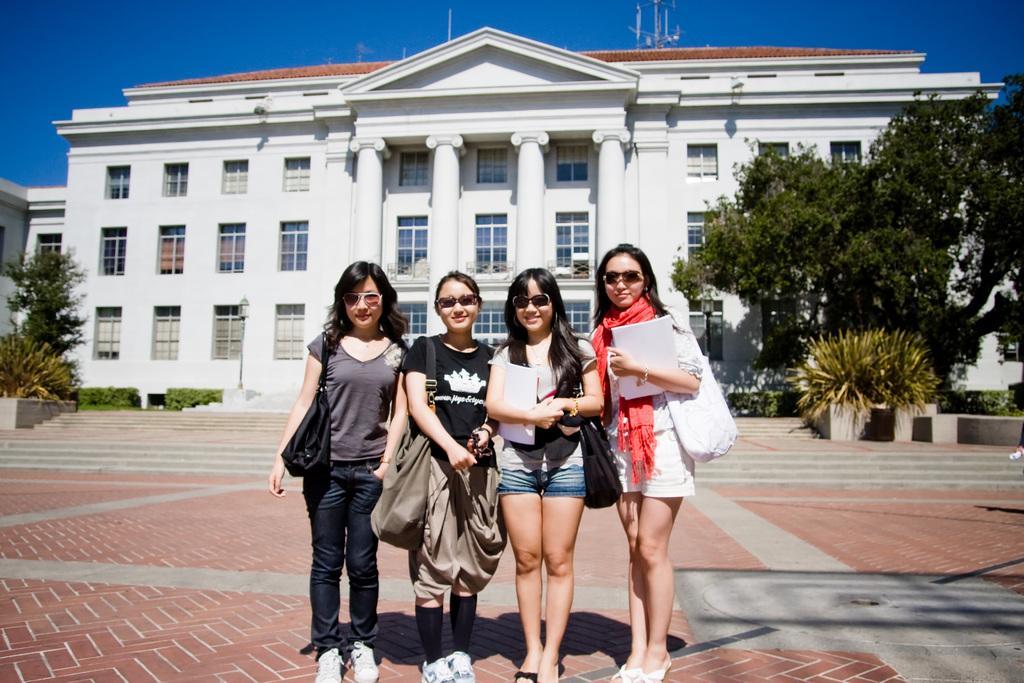Please provide a concise description of this image. There are four women standing and smiling. They wore goggles, dresses and footwear. These are the handbags. This is the building with windows and pillars. This building looks white in color. I can see bushes and plants. These are the trees with branches and leaves. I can see the stairs. 